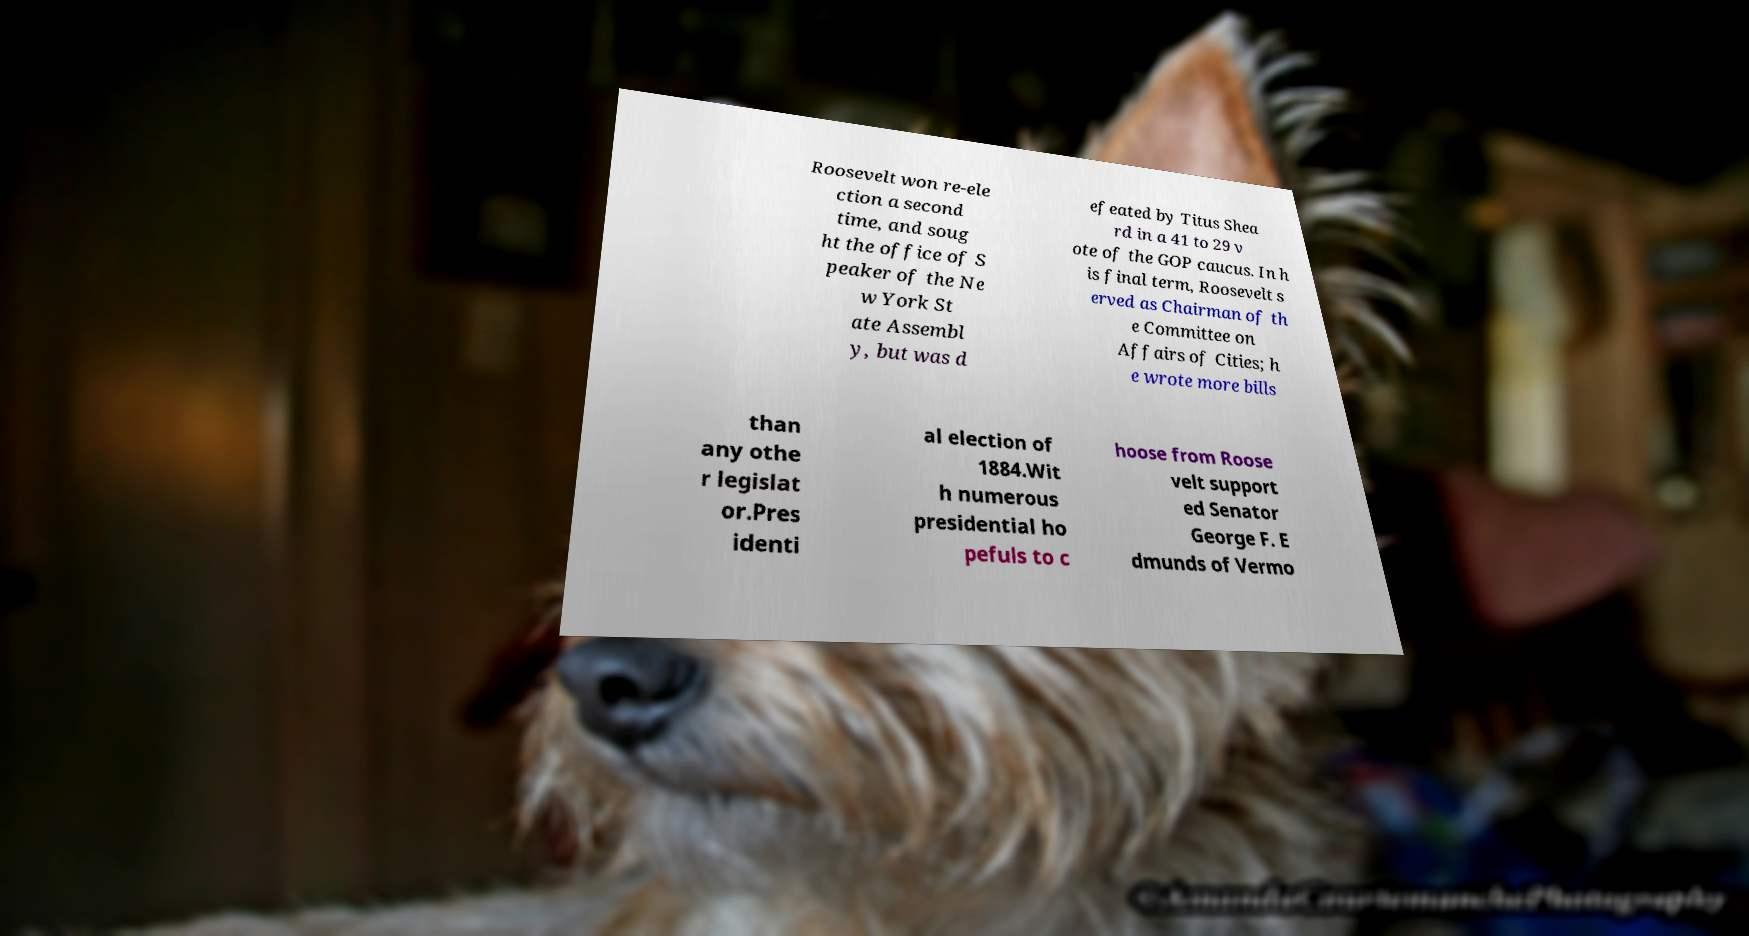Please identify and transcribe the text found in this image. Roosevelt won re-ele ction a second time, and soug ht the office of S peaker of the Ne w York St ate Assembl y, but was d efeated by Titus Shea rd in a 41 to 29 v ote of the GOP caucus. In h is final term, Roosevelt s erved as Chairman of th e Committee on Affairs of Cities; h e wrote more bills than any othe r legislat or.Pres identi al election of 1884.Wit h numerous presidential ho pefuls to c hoose from Roose velt support ed Senator George F. E dmunds of Vermo 